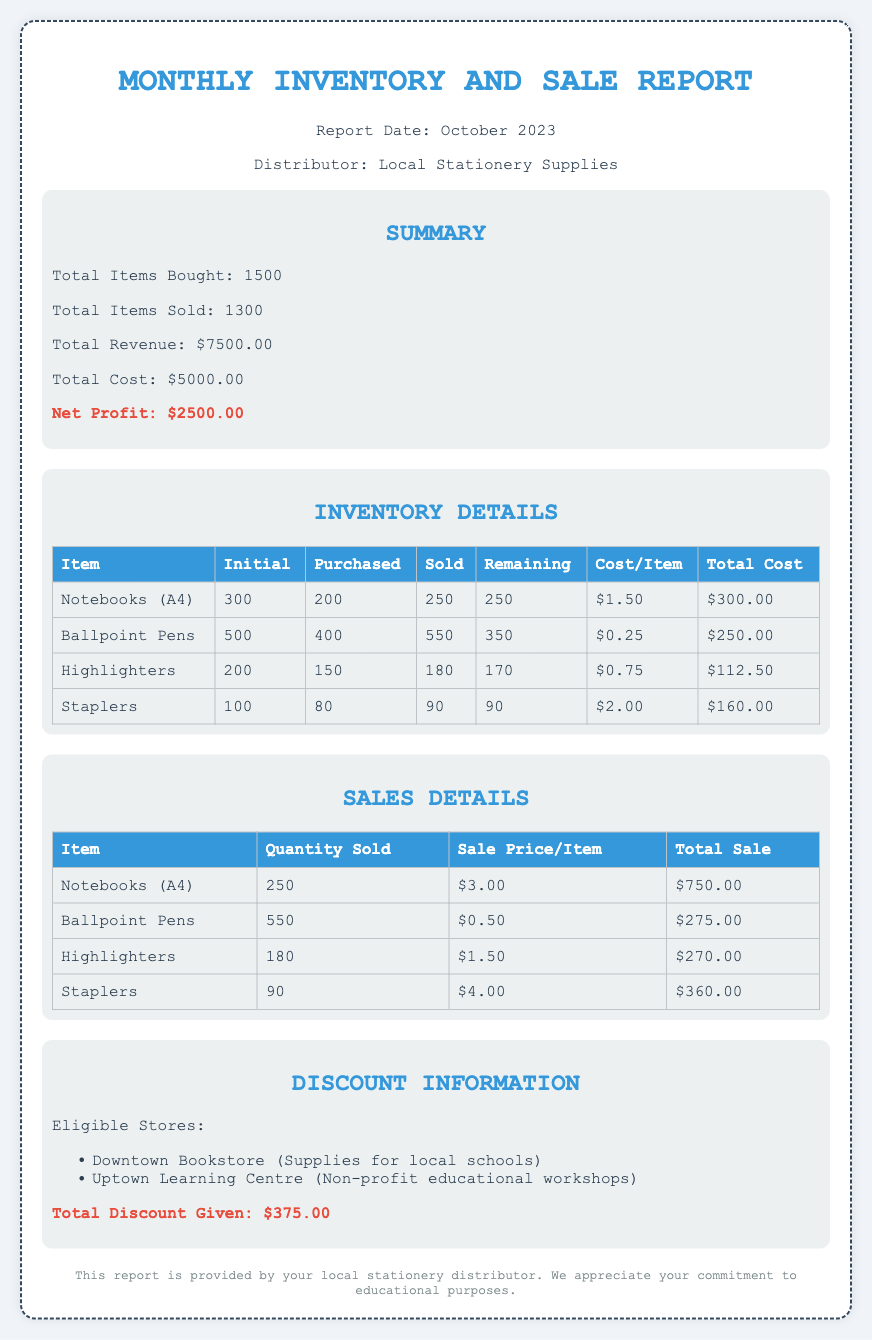What is the total items bought? The total items bought is explicitly mentioned in the summary section of the document.
Answer: 1500 What is the net profit? The net profit is derived from total revenue minus total cost as shown in the summary section.
Answer: $2500.00 How many highlighters were sold? The quantity sold for highlighters is provided in the sales details table.
Answer: 180 What is the total discount given? The total discount given is listed in the discount information section of the document.
Answer: $375.00 What was the cost per item for staplers? The cost per item for staplers is found in the inventory details table.
Answer: $2.00 Which store is eligible for discounts that supports non-profit educational workshops? An eligible store supporting non-profit educational workshops is mentioned in the discount information section.
Answer: Uptown Learning Centre What is the remaining quantity of ballpoint pens? The remaining quantity for ballpoint pens is indicated in the inventory details table.
Answer: 350 What was the sale price per item for notebooks? The sale price per item for notebooks can be found in the sales details table.
Answer: $3.00 How many items were sold in total? The total items sold is provided in the summary section.
Answer: 1300 